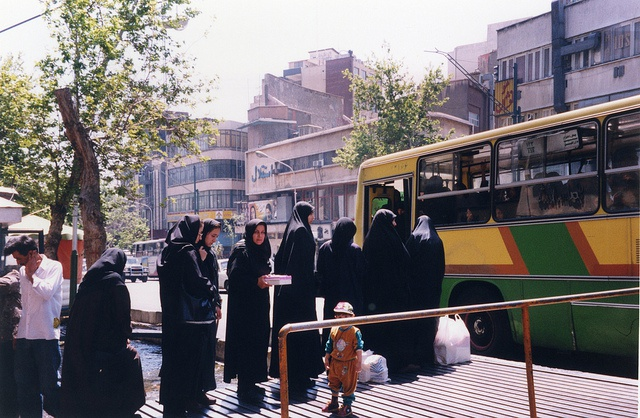Describe the objects in this image and their specific colors. I can see bus in white, black, gray, maroon, and darkgreen tones, people in white, black, gray, and darkgray tones, people in white, black, gray, navy, and darkgray tones, people in white, black, gray, and lightgray tones, and people in white, black, gray, darkgray, and maroon tones in this image. 